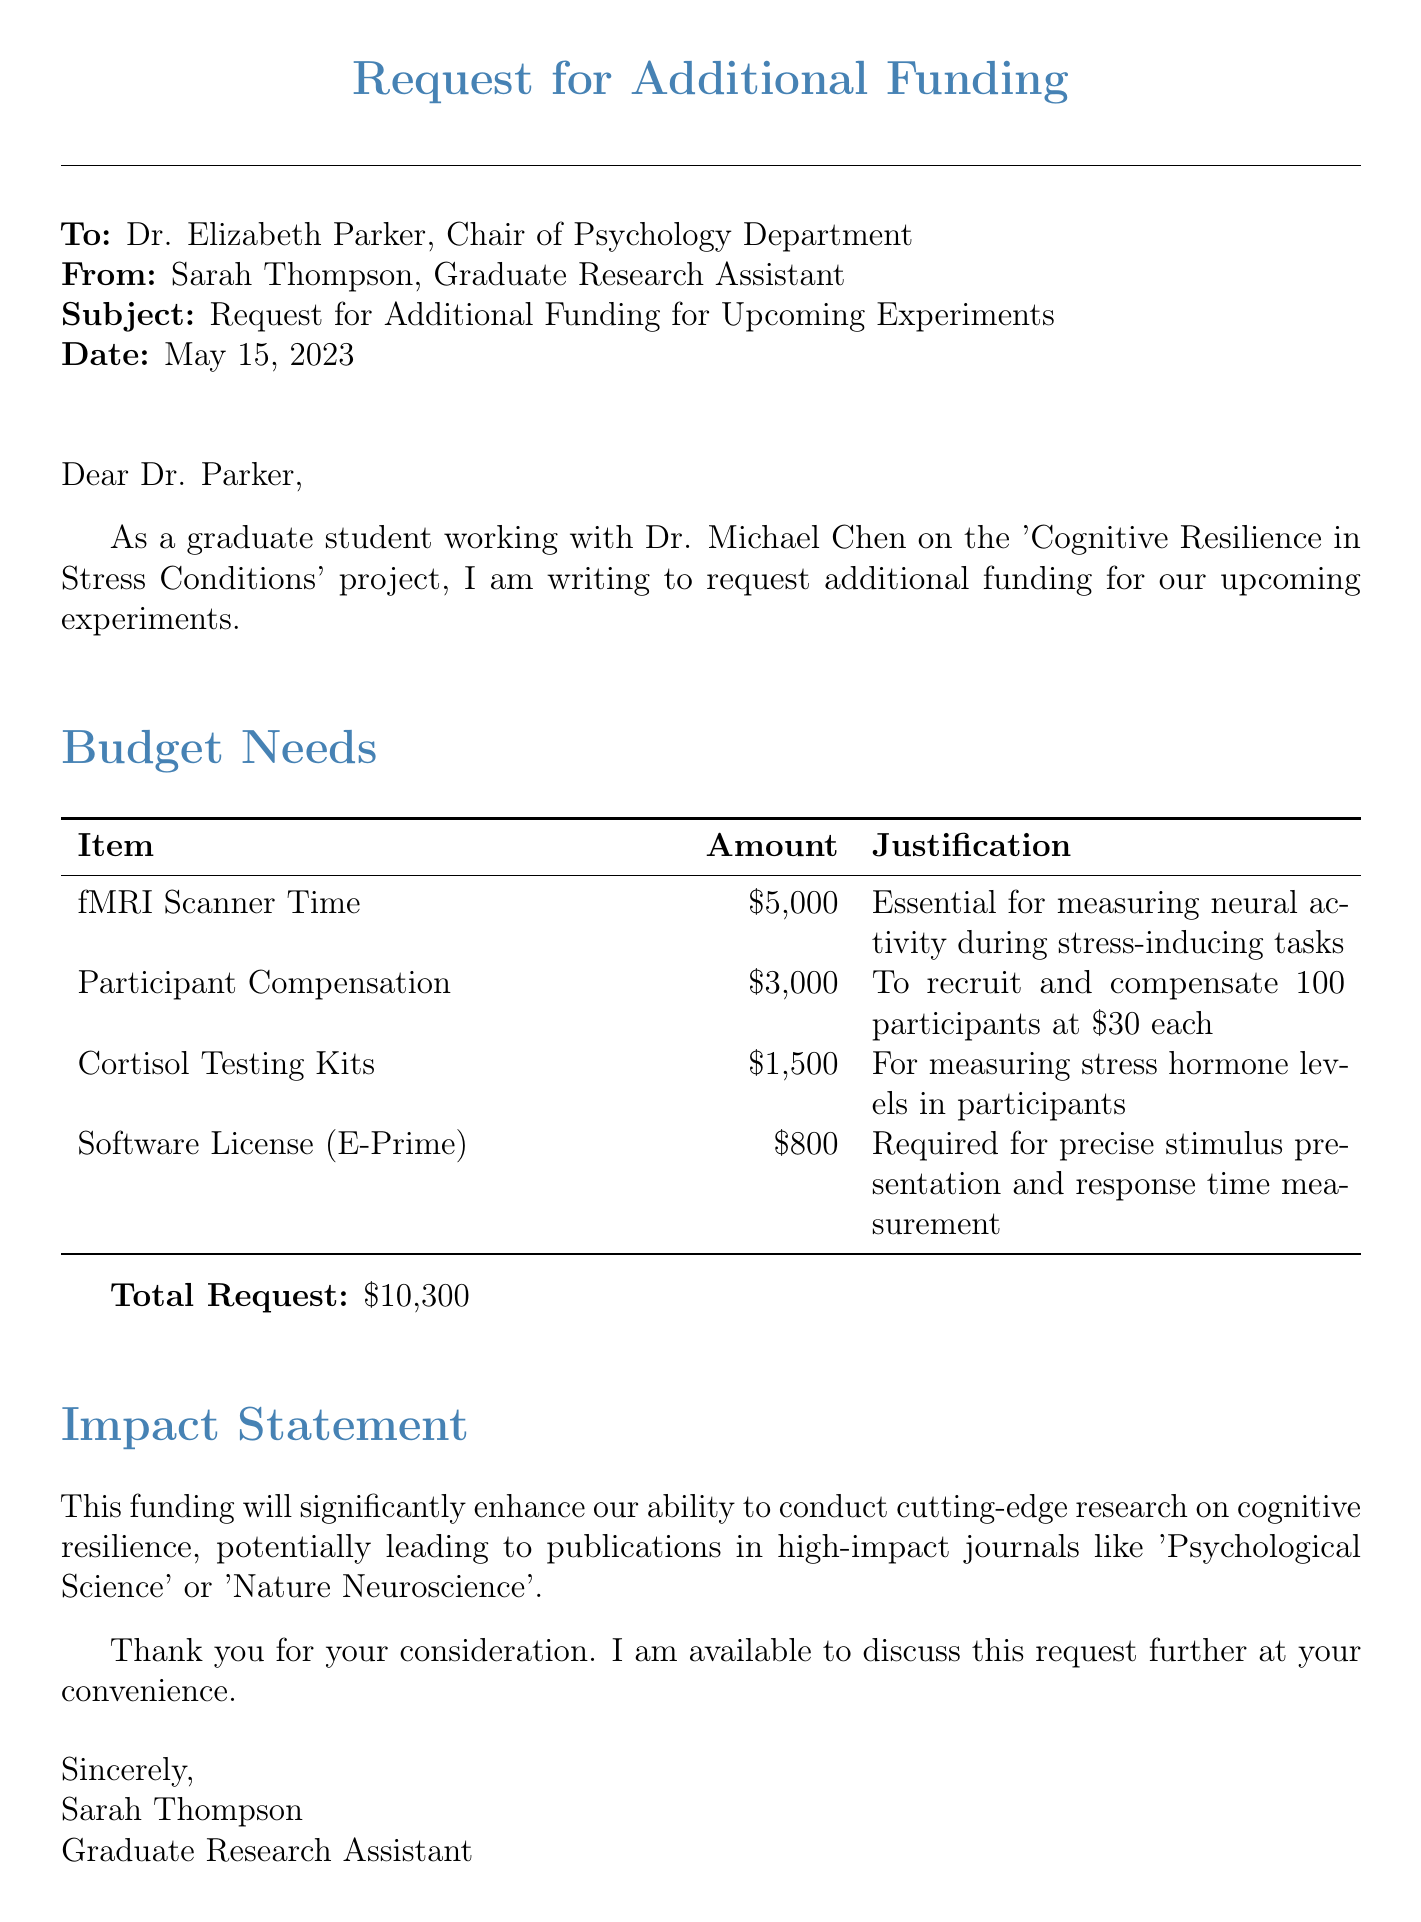what is the total funding requested? The total funding requested is explicitly stated in the document as $10,300.
Answer: $10,300 who is the recipient of this request? The recipient of this request is mentioned at the beginning of the document as Dr. Elizabeth Parker.
Answer: Dr. Elizabeth Parker what is the subject of the request? The subject of the request is clearly outlined as "Request for Additional Funding for Upcoming Experiments."
Answer: Request for Additional Funding for Upcoming Experiments how much is allocated for Participant Compensation? The budget item for Participant Compensation states that $3,000 is allocated for this purpose.
Answer: $3,000 what is one potential impact of this funding? The document specifies that the funding could lead to publications in high-impact journals like 'Psychological Science' or 'Nature Neuroscience.'
Answer: publications in high-impact journals how many participants are to be recruited? The document specifies that 100 participants are to be recruited and compensated.
Answer: 100 participants what is the purpose of the fMRI Scanner Time? The justification given states it is essential for measuring neural activity during stress-inducing tasks.
Answer: measuring neural activity who is the sender of this request? The sender of the request is identified as Sarah Thompson, Graduate Research Assistant.
Answer: Sarah Thompson on what date was this request made? The date of the request is clearly mentioned as May 15, 2023.
Answer: May 15, 2023 